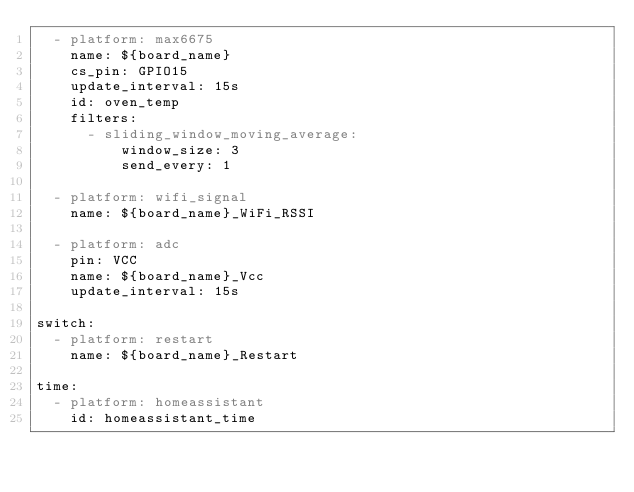Convert code to text. <code><loc_0><loc_0><loc_500><loc_500><_YAML_>  - platform: max6675
    name: ${board_name}
    cs_pin: GPIO15
    update_interval: 15s
    id: oven_temp
    filters:
      - sliding_window_moving_average:
          window_size: 3
          send_every: 1    
          
  - platform: wifi_signal
    name: ${board_name}_WiFi_RSSI

  - platform: adc
    pin: VCC
    name: ${board_name}_Vcc
    update_interval: 15s    

switch:
  - platform: restart
    name: ${board_name}_Restart

time:
  - platform: homeassistant
    id: homeassistant_time</code> 